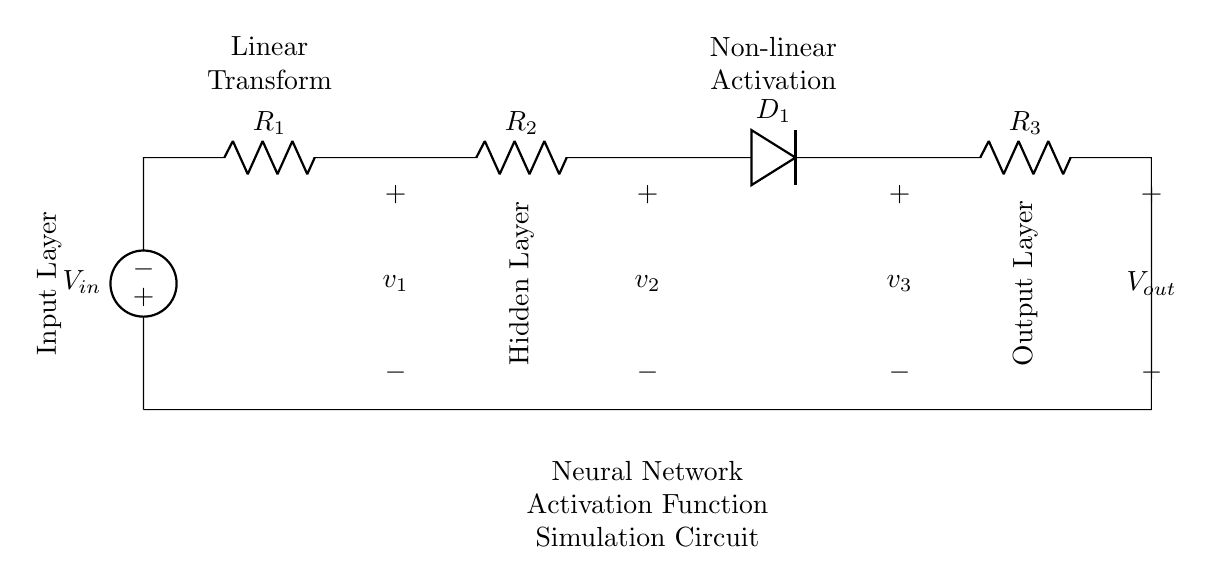What is the input voltage? The input voltage is labeled as V_in, which is the source voltage supplied to the circuit.
Answer: V_in How many resistors are in the circuit? The circuit contains three resistors, denoted as R_1, R_2, and R_3.
Answer: three What components are associated with the activation function? The diode D_1 is specifically associated with the non-linear activation function in the hidden layer, which simulates the non-linear transformation.
Answer: D_1 What is the role of R_1? R_1 serves as a linear transform in the circuit, contributing to the overall resistance and affecting the voltage drop across it.
Answer: Linear Transform What is the output voltage of the circuit? The output voltage, labeled as V_out, is the voltage across the last resistor R_3, taking into account the influence of previous components in the circuit.
Answer: V_out How is the activation function simulated in this circuit? The simulation of the activation function is done through non-linear behavior introduced by the diode D_1, which allows current to flow in one direction, creating the conditions for non-linearity in output signaling.
Answer: Diode D_1 What distinguishes the hidden layer in this circuit? The hidden layer is distinguished by the presence of the non-linear activation component (D_1) that affects how the output is calculated based on input through various resistances.
Answer: Non-linear Activation 